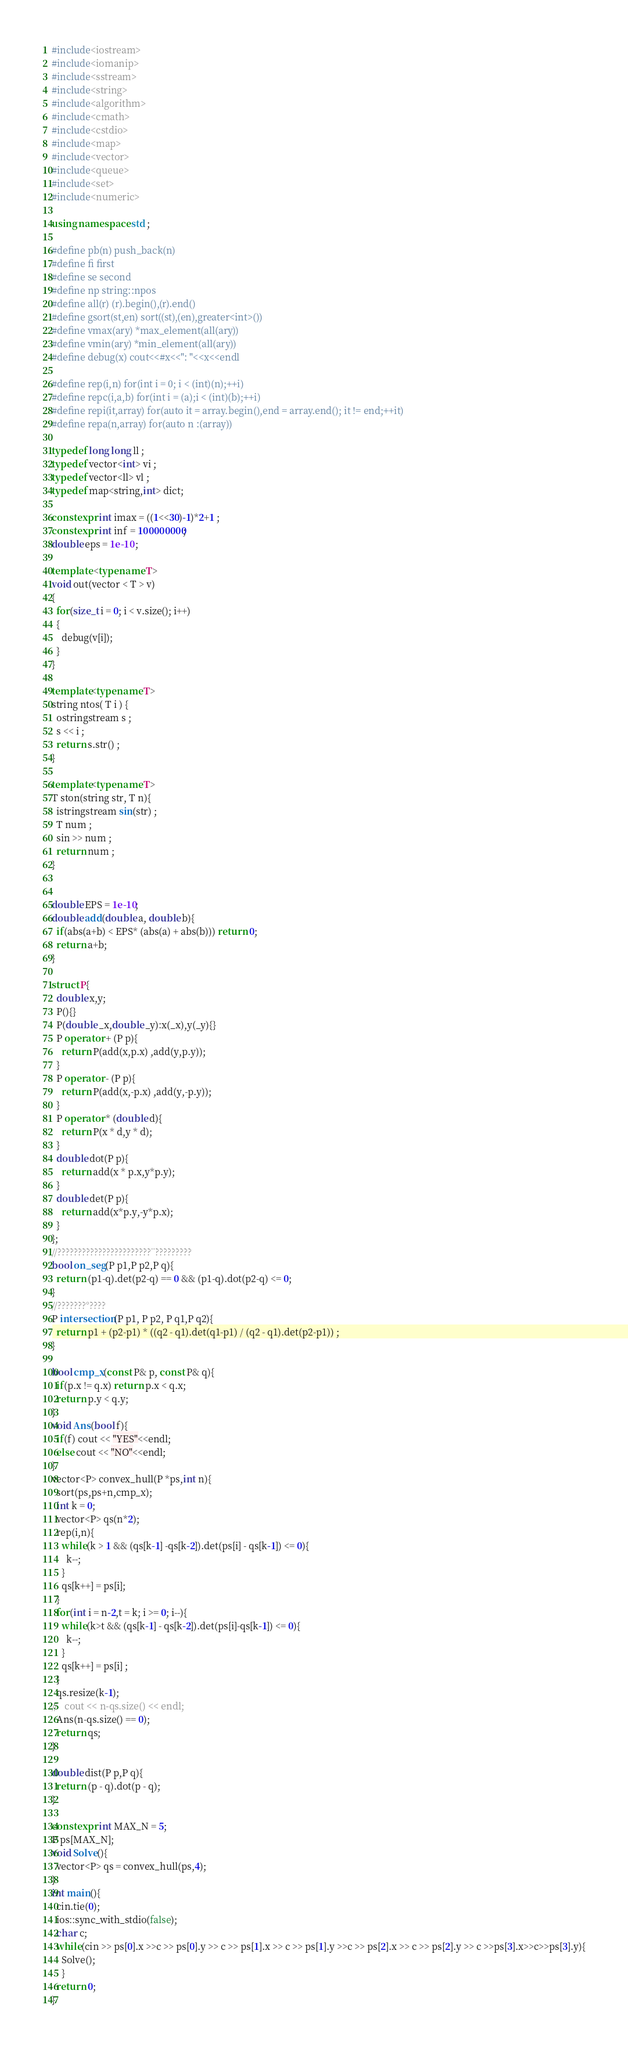Convert code to text. <code><loc_0><loc_0><loc_500><loc_500><_C++_>#include<iostream>
#include<iomanip>
#include<sstream>
#include<string>
#include<algorithm>
#include<cmath>
#include<cstdio>
#include<map>
#include<vector>
#include<queue>
#include<set>
#include<numeric>

using namespace std ;

#define pb(n) push_back(n)
#define fi first
#define se second
#define np string::npos
#define all(r) (r).begin(),(r).end()
#define gsort(st,en) sort((st),(en),greater<int>())
#define vmax(ary) *max_element(all(ary))
#define vmin(ary) *min_element(all(ary))
#define debug(x) cout<<#x<<": "<<x<<endl

#define rep(i,n) for(int i = 0; i < (int)(n);++i)
#define repc(i,a,b) for(int i = (a);i < (int)(b);++i)
#define repi(it,array) for(auto it = array.begin(),end = array.end(); it != end;++it)
#define repa(n,array) for(auto n :(array))

typedef long long ll ;
typedef vector<int> vi ;
typedef vector<ll> vl ;
typedef map<string,int> dict;

constexpr int imax = ((1<<30)-1)*2+1 ;
constexpr int inf = 100000000;
double eps = 1e-10 ;

template <typename T>
void out(vector < T > v)
{
  for(size_t i = 0; i < v.size(); i++)
  {
    debug(v[i]);
  }
}

template<typename T>
string ntos( T i ) {
  ostringstream s ;
  s << i ;
  return s.str() ;
}

template<typename T>
T ston(string str, T n){
  istringstream sin(str) ;
  T num ;
  sin >> num ;
  return num ;
}


double EPS = 1e-10;
double add(double a, double b){
  if(abs(a+b) < EPS* (abs(a) + abs(b))) return 0;
  return a+b;
}

struct P{
  double x,y;
  P(){}
  P(double _x,double _y):x(_x),y(_y){}
  P operator + (P p){
    return P(add(x,p.x) ,add(y,p.y));
  }
  P operator - (P p){
    return P(add(x,-p.x) ,add(y,-p.y));
  }
  P operator * (double d){
    return P(x * d,y * d);
  }
  double dot(P p){
    return add(x * p.x,y*p.y);
  }
  double det(P p){
    return add(x*p.y,-y*p.x);
  }
};
//???????????????????????¨?????????
bool on_seg(P p1,P p2,P q){
  return (p1-q).det(p2-q) == 0 && (p1-q).dot(p2-q) <= 0;
}
//???????°????
P intersection(P p1, P p2, P q1,P q2){
  return p1 + (p2-p1) * ((q2 - q1).det(q1-p1) / (q2 - q1).det(p2-p1)) ;
}

bool cmp_x(const P& p, const P& q){
  if(p.x != q.x) return p.x < q.x;
  return p.y < q.y;
}
void Ans(bool f){
  if(f) cout << "YES"<<endl;
  else cout << "NO"<<endl;
}
vector<P> convex_hull(P *ps,int n){
  sort(ps,ps+n,cmp_x);
  int k = 0;
  vector<P> qs(n*2);
  rep(i,n){
    while(k > 1 && (qs[k-1] -qs[k-2]).det(ps[i] - qs[k-1]) <= 0){
      k--;
    }
    qs[k++] = ps[i];
  }
  for(int i = n-2,t = k; i >= 0; i--){
    while(k>t && (qs[k-1] - qs[k-2]).det(ps[i]-qs[k-1]) <= 0){
      k--;
    }
    qs[k++] = ps[i] ;
  }
  qs.resize(k-1);
//   cout << n-qs.size() << endl;
  Ans(n-qs.size() == 0);
  return qs;
}

double dist(P p,P q){
  return (p - q).dot(p - q);
}

constexpr int MAX_N = 5;
P ps[MAX_N];
void Solve(){
  vector<P> qs = convex_hull(ps,4);
}
int main(){
  cin.tie(0);
  ios::sync_with_stdio(false);
  char c;
  while(cin >> ps[0].x >>c >> ps[0].y >> c >> ps[1].x >> c >> ps[1].y >>c >> ps[2].x >> c >> ps[2].y >> c >>ps[3].x>>c>>ps[3].y){
    Solve();
    }
  return 0;
}</code> 